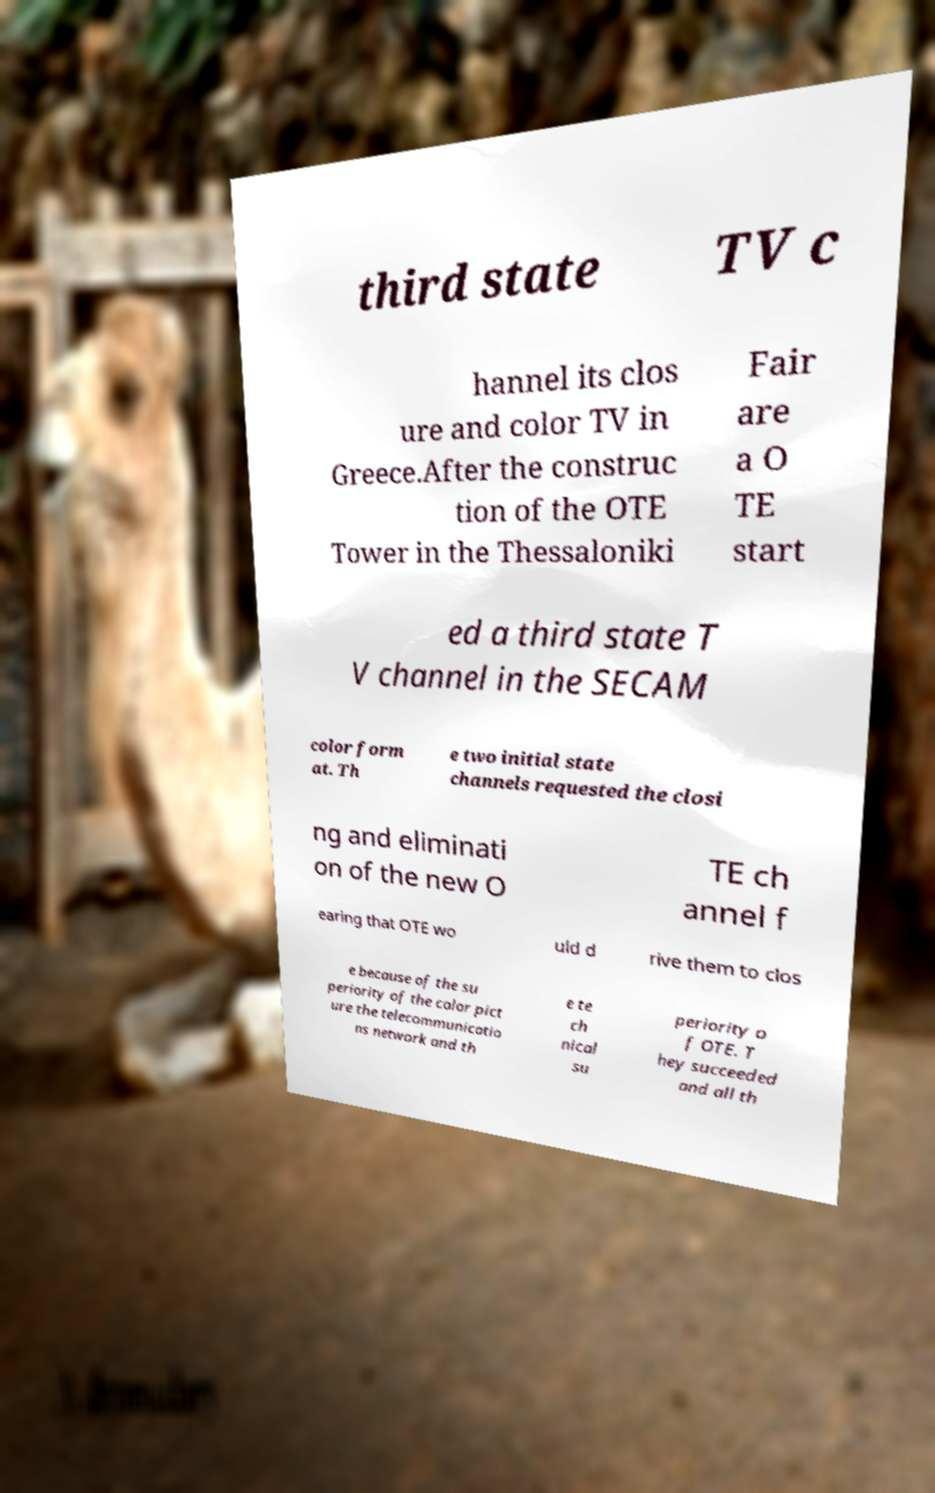For documentation purposes, I need the text within this image transcribed. Could you provide that? third state TV c hannel its clos ure and color TV in Greece.After the construc tion of the OTE Tower in the Thessaloniki Fair are a O TE start ed a third state T V channel in the SECAM color form at. Th e two initial state channels requested the closi ng and eliminati on of the new O TE ch annel f earing that OTE wo uld d rive them to clos e because of the su periority of the color pict ure the telecommunicatio ns network and th e te ch nical su periority o f OTE. T hey succeeded and all th 